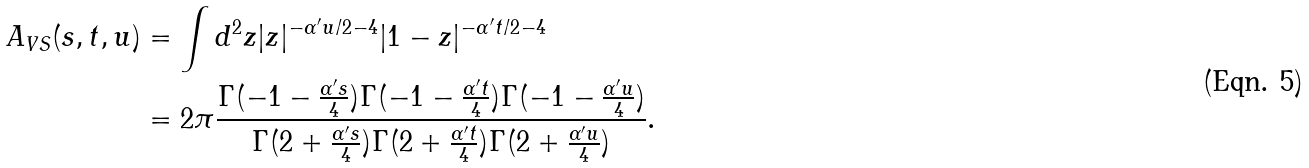Convert formula to latex. <formula><loc_0><loc_0><loc_500><loc_500>A _ { V S } ( s , t , u ) & = \int d ^ { 2 } z | z | ^ { - \alpha ^ { \prime } u / 2 - 4 } | 1 - z | ^ { - \alpha ^ { \prime } t / 2 - 4 } \\ & = 2 \pi \frac { \Gamma ( - 1 - \frac { \alpha ^ { \prime } s } { 4 } ) \Gamma ( - 1 - \frac { \alpha ^ { \prime } t } { 4 } ) \Gamma ( - 1 - \frac { \alpha ^ { \prime } u } { 4 } ) } { \Gamma ( 2 + \frac { \alpha ^ { \prime } s } { 4 } ) \Gamma ( 2 + \frac { \alpha ^ { \prime } t } { 4 } ) \Gamma ( 2 + \frac { \alpha ^ { \prime } u } { 4 } ) } .</formula> 